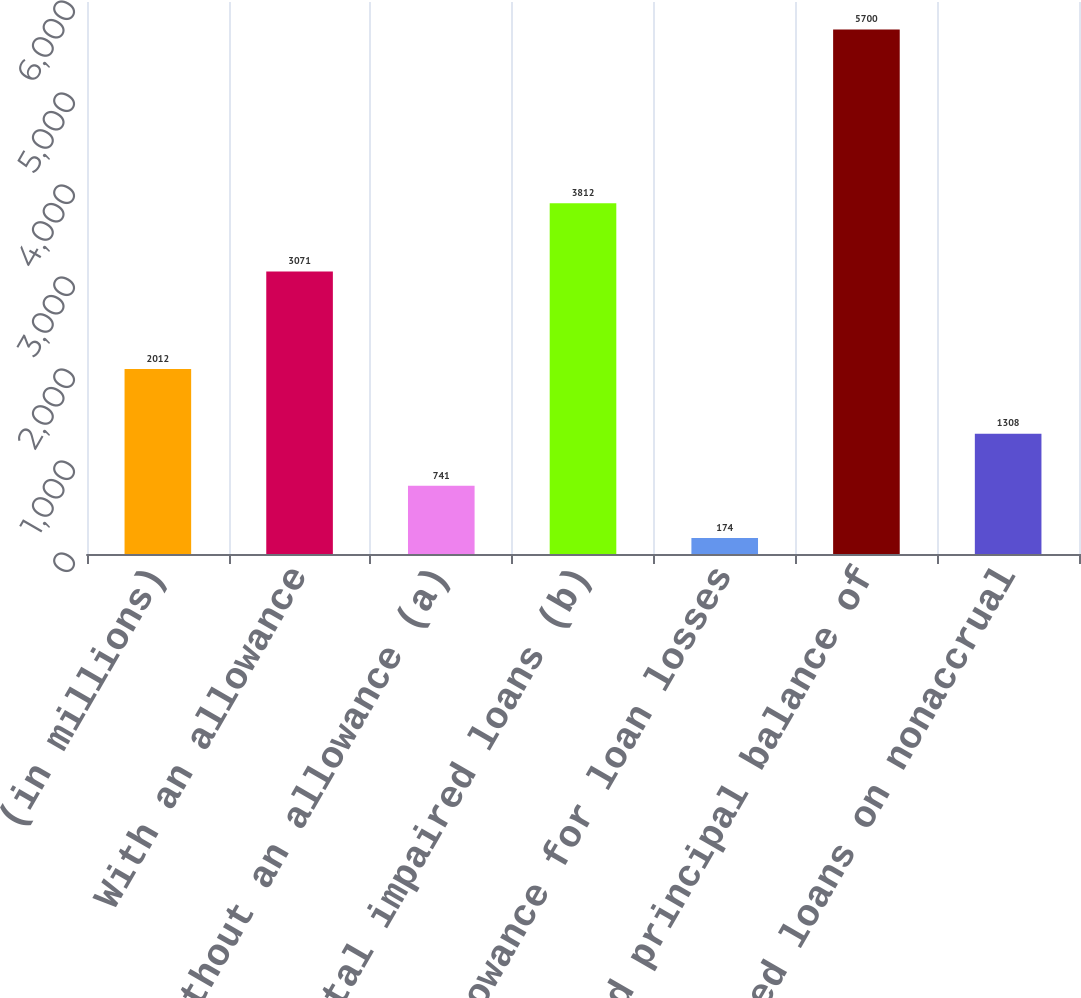Convert chart to OTSL. <chart><loc_0><loc_0><loc_500><loc_500><bar_chart><fcel>(in millions)<fcel>With an allowance<fcel>Without an allowance (a)<fcel>Total impaired loans (b)<fcel>Allowance for loan losses<fcel>Unpaid principal balance of<fcel>Impaired loans on nonaccrual<nl><fcel>2012<fcel>3071<fcel>741<fcel>3812<fcel>174<fcel>5700<fcel>1308<nl></chart> 